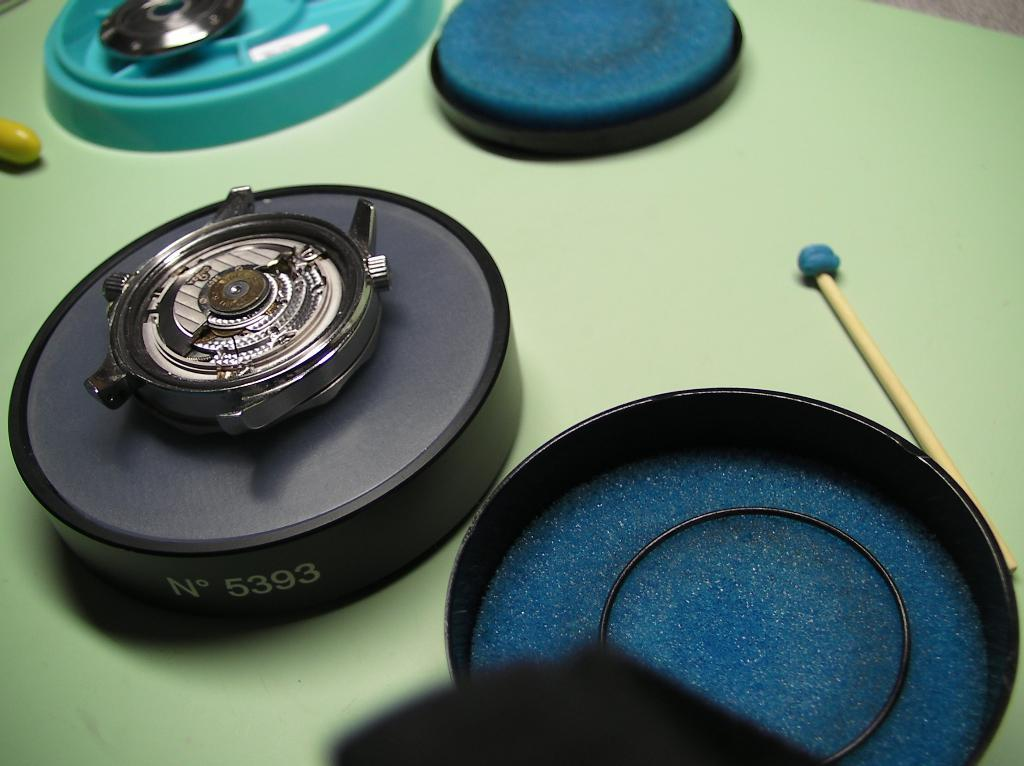<image>
Relay a brief, clear account of the picture shown. A device on a table has the number 5393 on it. 